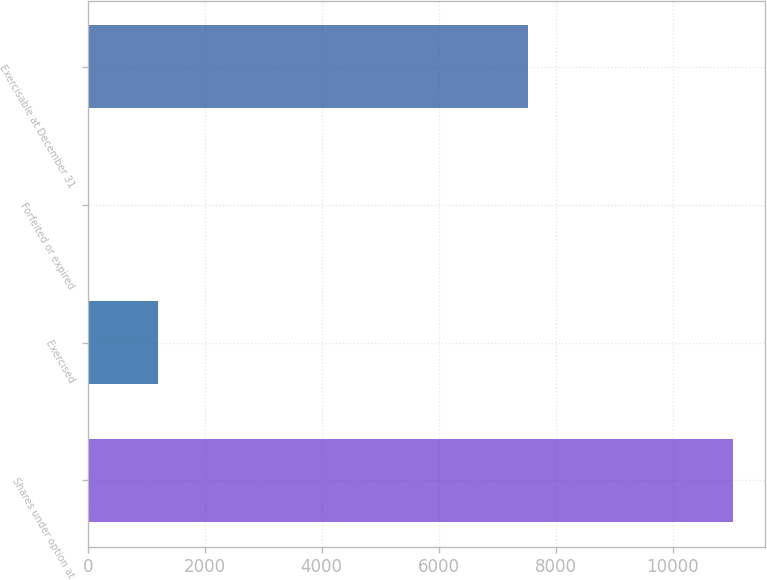Convert chart. <chart><loc_0><loc_0><loc_500><loc_500><bar_chart><fcel>Shares under option at<fcel>Exercised<fcel>Forfeited or expired<fcel>Exercisable at December 31<nl><fcel>11026<fcel>1207.6<fcel>17<fcel>7532<nl></chart> 